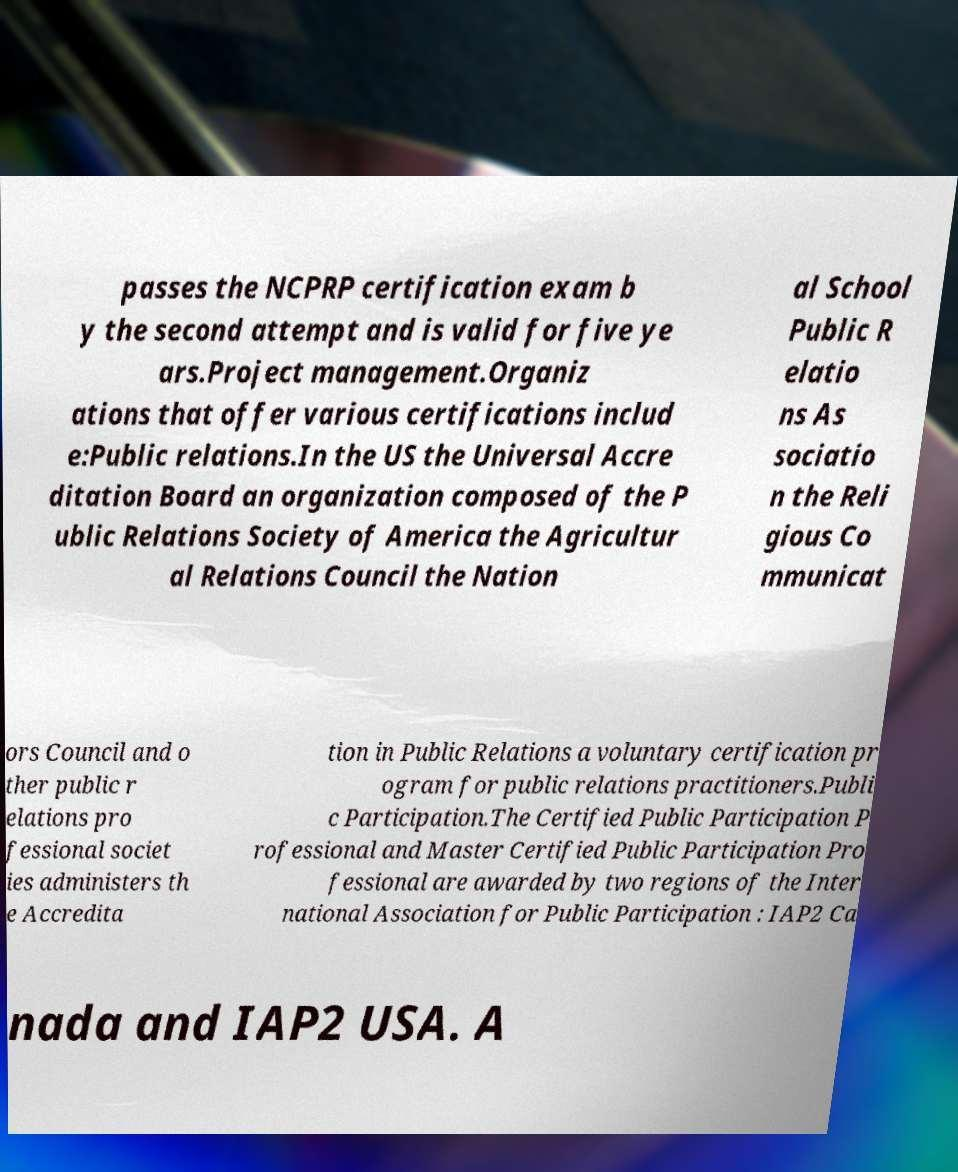What messages or text are displayed in this image? I need them in a readable, typed format. passes the NCPRP certification exam b y the second attempt and is valid for five ye ars.Project management.Organiz ations that offer various certifications includ e:Public relations.In the US the Universal Accre ditation Board an organization composed of the P ublic Relations Society of America the Agricultur al Relations Council the Nation al School Public R elatio ns As sociatio n the Reli gious Co mmunicat ors Council and o ther public r elations pro fessional societ ies administers th e Accredita tion in Public Relations a voluntary certification pr ogram for public relations practitioners.Publi c Participation.The Certified Public Participation P rofessional and Master Certified Public Participation Pro fessional are awarded by two regions of the Inter national Association for Public Participation : IAP2 Ca nada and IAP2 USA. A 